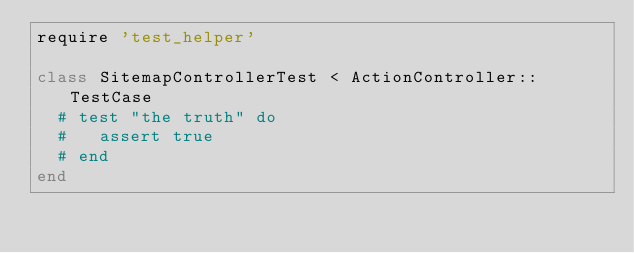<code> <loc_0><loc_0><loc_500><loc_500><_Ruby_>require 'test_helper'

class SitemapControllerTest < ActionController::TestCase
  # test "the truth" do
  #   assert true
  # end
end
</code> 